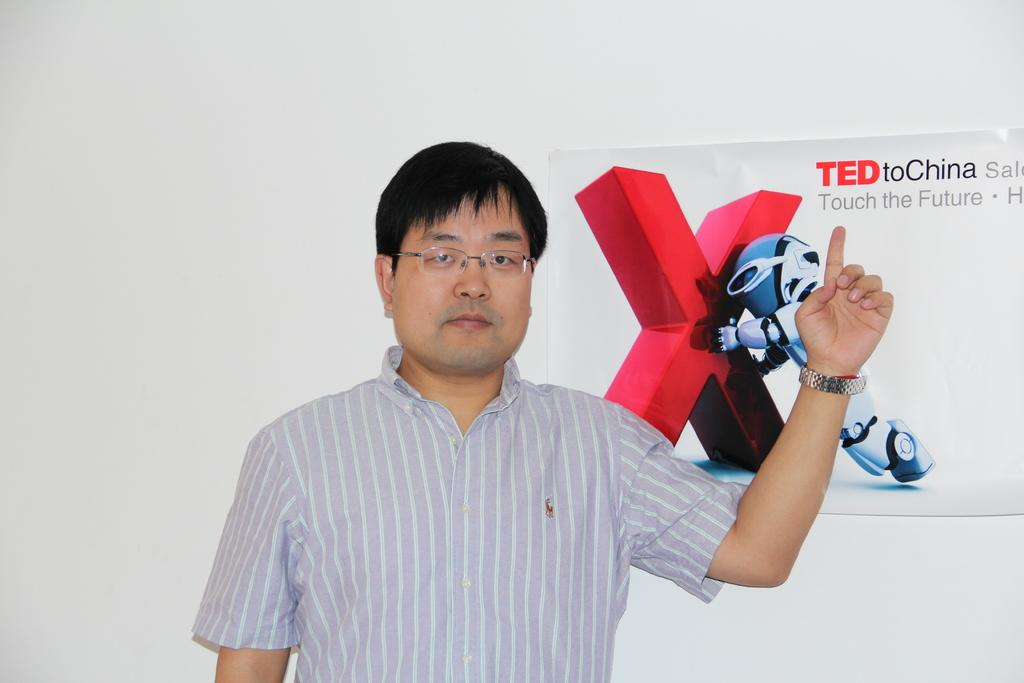What is the main subject of the image? There is a person in the image. Can you describe anything in the background of the image? There is a poster on the wall in the background of the image. What type of vein is visible on the person's arm in the image? There is no visible vein on the person's arm in the image. How does the person push the air out of the room in the image? The person does not push air out of the room in the image; there is no indication of such an action. 